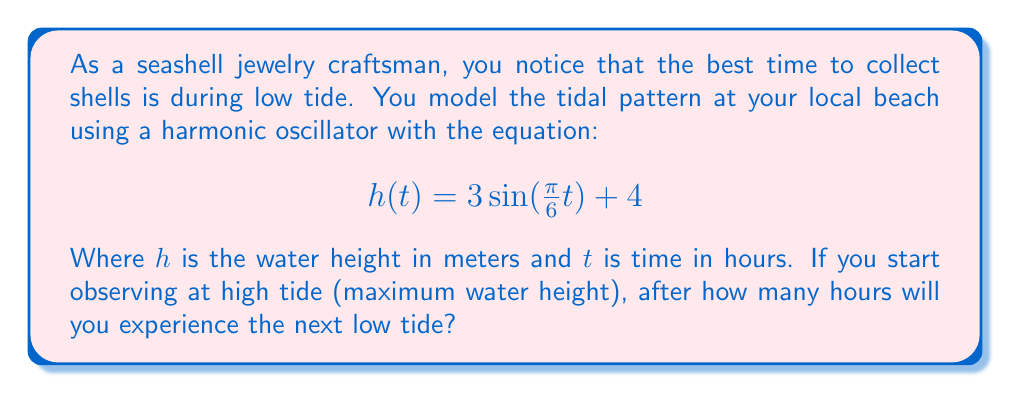Teach me how to tackle this problem. Let's approach this step-by-step:

1) The given equation is in the form of a sine function:
   $$h(t) = A\sin(\omega t) + B$$
   Where $A = 3$ (amplitude), $\omega = \frac{\pi}{6}$ (angular frequency), and $B = 4$ (vertical shift).

2) The period of a sine function is given by $T = \frac{2\pi}{\omega}$. Here:
   $$T = \frac{2\pi}{\frac{\pi}{6}} = 12\text{ hours}$$

3) This means the tidal cycle repeats every 12 hours.

4) In a sine function, the distance between a maximum and the next minimum is half a period.

5) Therefore, the time from high tide to low tide is:
   $$\frac{T}{2} = \frac{12}{2} = 6\text{ hours}$$

6) We can verify this mathematically:
   - At $t = 0$ (start of observation), $h(0) = 3\sin(0) + 4 = 4 + 3 = 7$ (high tide)
   - At $t = 6$, $h(6) = 3\sin(\frac{\pi}{6} \cdot 6) + 4 = 3\sin(\pi) + 4 = -3 + 4 = 1$ (low tide)

Thus, the next low tide will occur 6 hours after the observed high tide.
Answer: 6 hours 